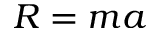Convert formula to latex. <formula><loc_0><loc_0><loc_500><loc_500>R = m a</formula> 